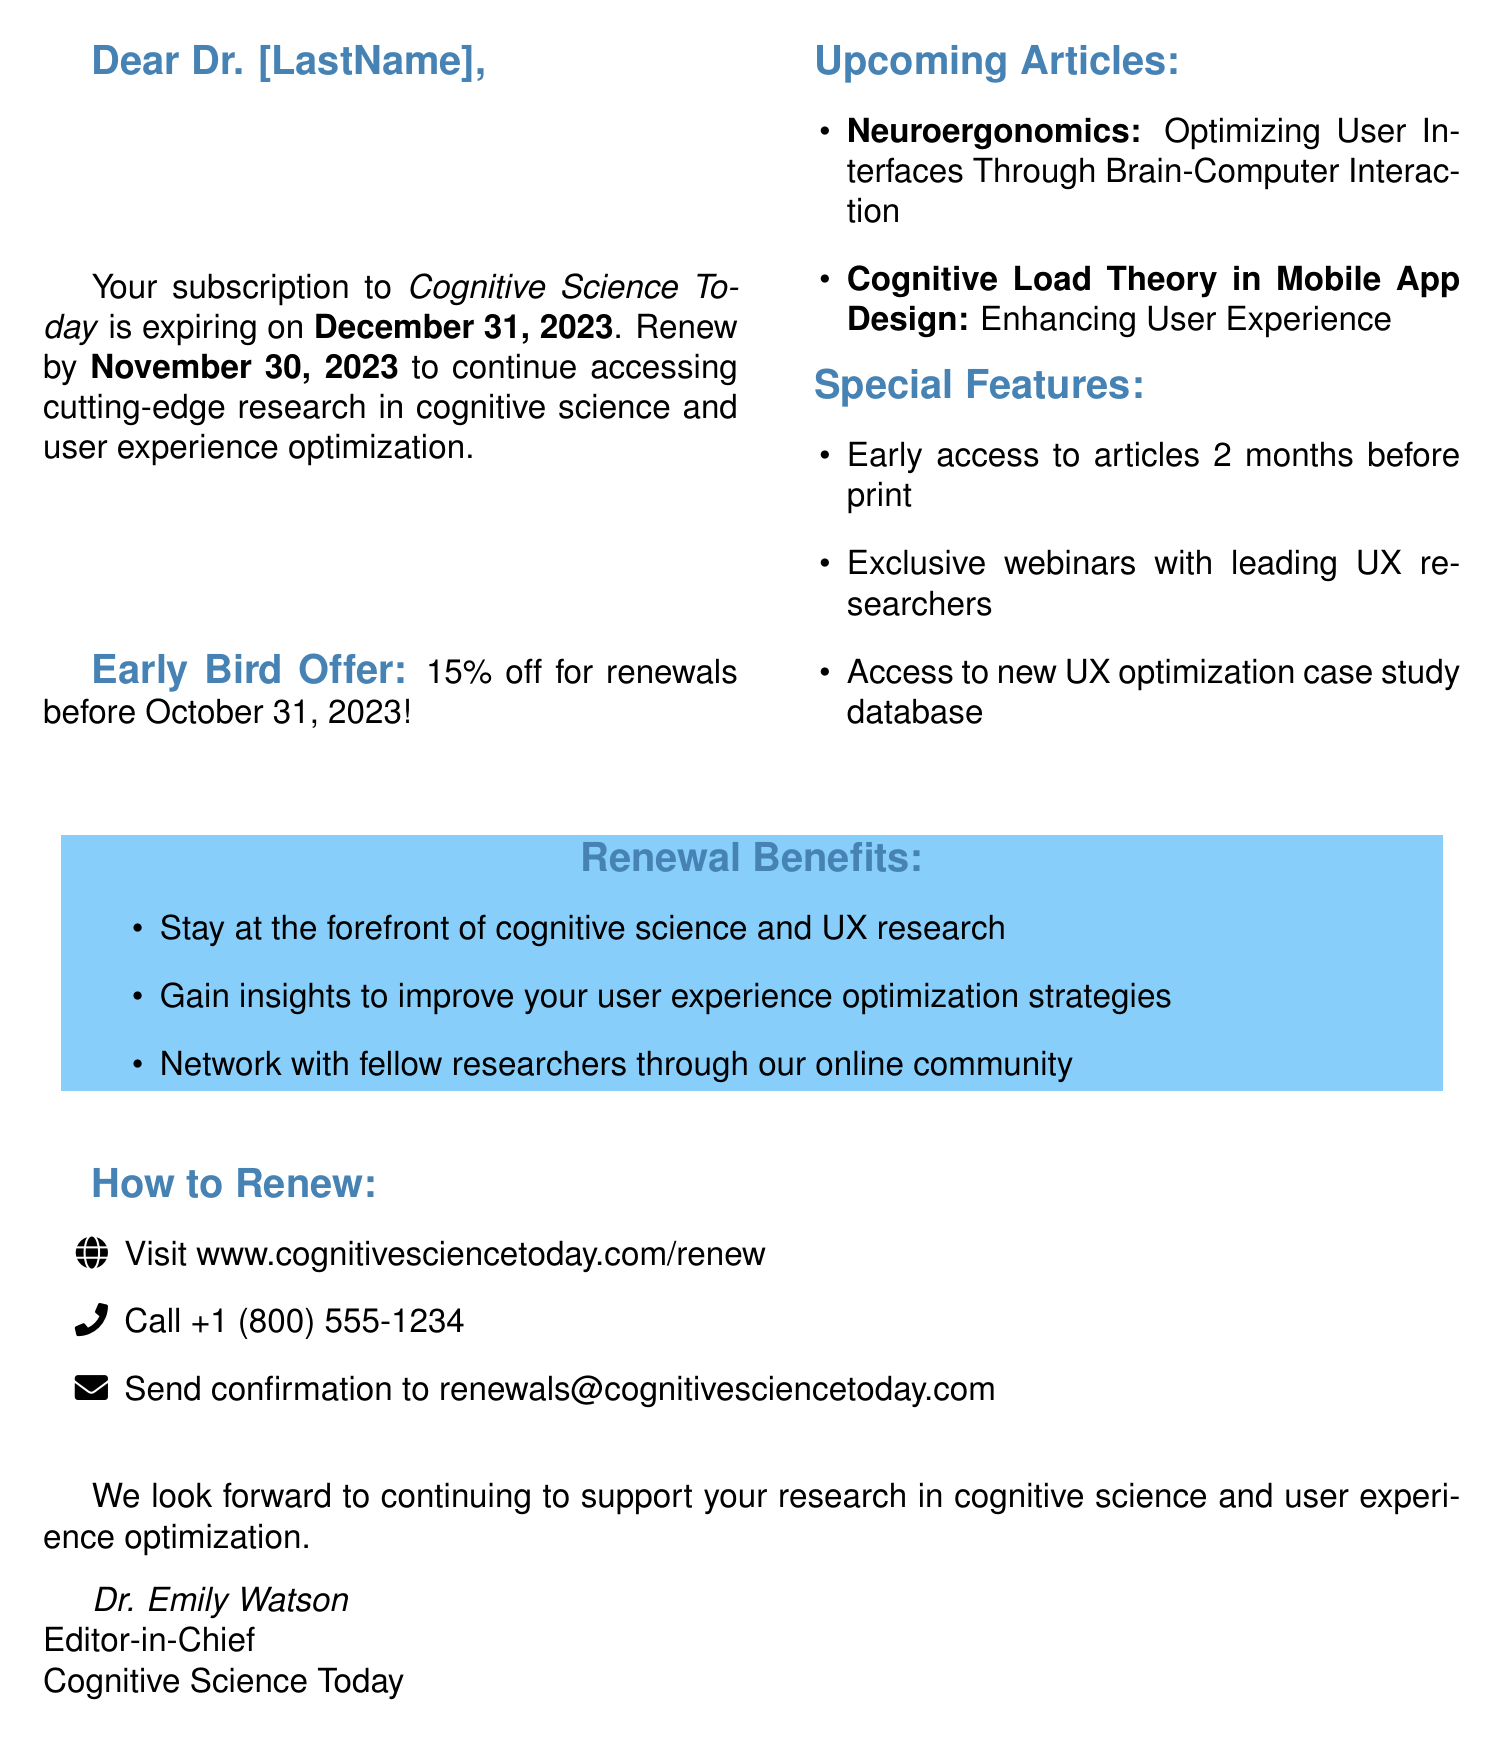What is the name of the journal? The name of the journal is specified in the document.
Answer: Cognitive Science Today What is the impact factor of the journal? The impact factor is a key performance indicator mentioned in the document.
Answer: 4.2 When does the subscription expire? The expiration date of the subscription is clearly stated in the document.
Answer: December 31, 2023 What is the early bird discount percentage? The document specifies the discount applicable for early renewals.
Answer: 15% off Who are the authors of the article on neuroergonomics? The authors' names are listed with the upcoming articles in the document.
Answer: Dr. Sarah Neufeld and Prof. Michael Chang What is one of the special features of renewing the subscription? The document lists several special features associated with the subscription renewal.
Answer: Early access to articles 2 months before print publication How can subscribers renew their subscription? The document outlines multiple options for renewal.
Answer: Visit www.cognitivesciencetoday.com/renew What is the renewal deadline? The document specifies when the renewal process must be completed.
Answer: November 30, 2023 What is one benefit of renewing the subscription? The document highlights various benefits that come with renewing.
Answer: Stay at the forefront of cognitive science and UX research 